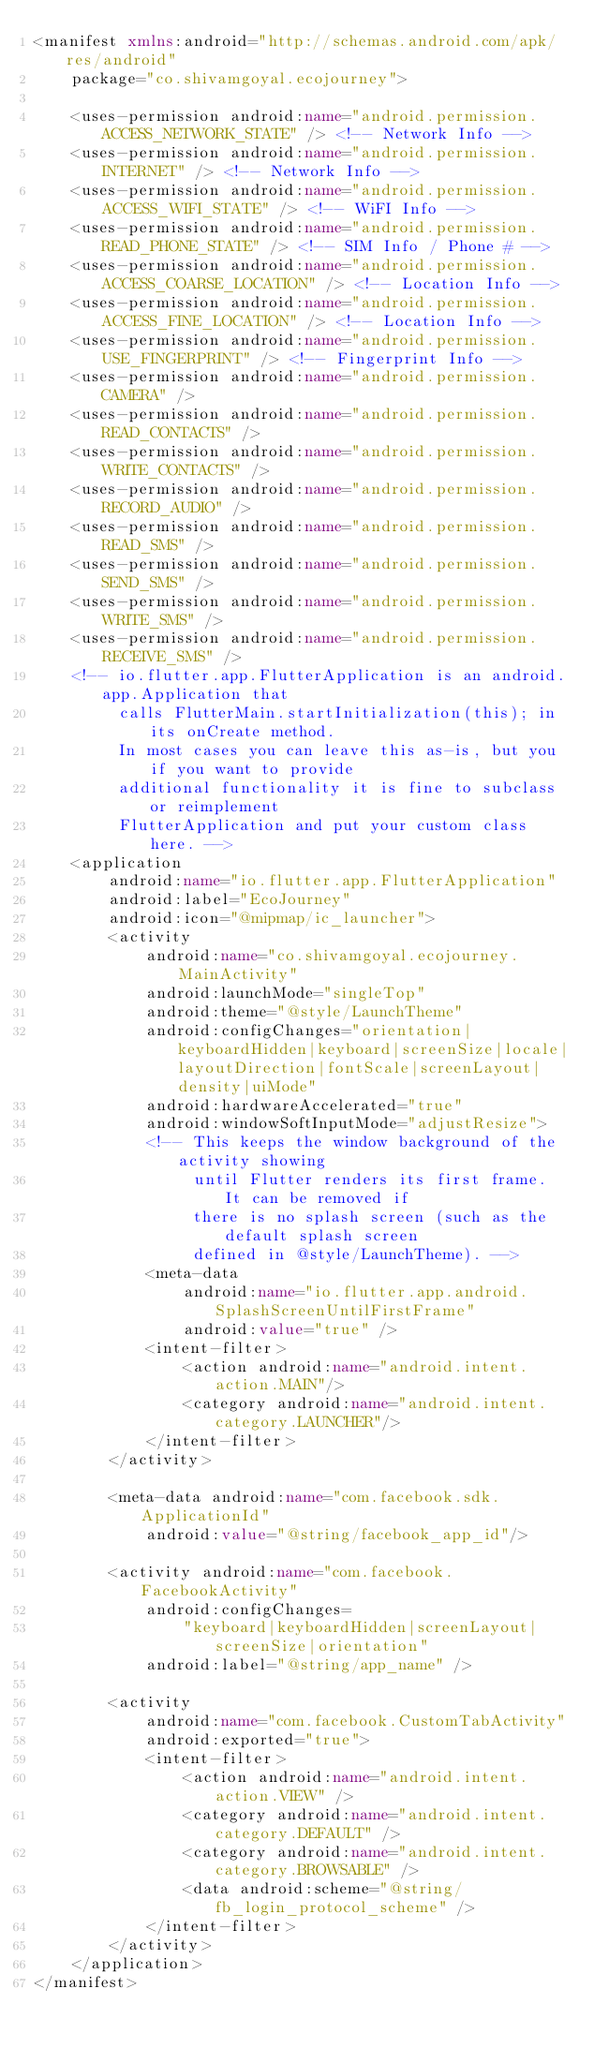Convert code to text. <code><loc_0><loc_0><loc_500><loc_500><_XML_><manifest xmlns:android="http://schemas.android.com/apk/res/android"
    package="co.shivamgoyal.ecojourney">

    <uses-permission android:name="android.permission.ACCESS_NETWORK_STATE" /> <!-- Network Info -->
    <uses-permission android:name="android.permission.INTERNET" /> <!-- Network Info -->
    <uses-permission android:name="android.permission.ACCESS_WIFI_STATE" /> <!-- WiFI Info -->
    <uses-permission android:name="android.permission.READ_PHONE_STATE" /> <!-- SIM Info / Phone # -->
    <uses-permission android:name="android.permission.ACCESS_COARSE_LOCATION" /> <!-- Location Info -->
    <uses-permission android:name="android.permission.ACCESS_FINE_LOCATION" /> <!-- Location Info -->
    <uses-permission android:name="android.permission.USE_FINGERPRINT" /> <!-- Fingerprint Info -->
    <uses-permission android:name="android.permission.CAMERA" />
    <uses-permission android:name="android.permission.READ_CONTACTS" />
    <uses-permission android:name="android.permission.WRITE_CONTACTS" />
    <uses-permission android:name="android.permission.RECORD_AUDIO" />
    <uses-permission android:name="android.permission.READ_SMS" />
    <uses-permission android:name="android.permission.SEND_SMS" />
    <uses-permission android:name="android.permission.WRITE_SMS" />
    <uses-permission android:name="android.permission.RECEIVE_SMS" />
    <!-- io.flutter.app.FlutterApplication is an android.app.Application that
         calls FlutterMain.startInitialization(this); in its onCreate method.
         In most cases you can leave this as-is, but you if you want to provide
         additional functionality it is fine to subclass or reimplement
         FlutterApplication and put your custom class here. -->
    <application
        android:name="io.flutter.app.FlutterApplication"
        android:label="EcoJourney"
        android:icon="@mipmap/ic_launcher">
        <activity
            android:name="co.shivamgoyal.ecojourney.MainActivity"
            android:launchMode="singleTop"
            android:theme="@style/LaunchTheme"
            android:configChanges="orientation|keyboardHidden|keyboard|screenSize|locale|layoutDirection|fontScale|screenLayout|density|uiMode"
            android:hardwareAccelerated="true"
            android:windowSoftInputMode="adjustResize">
            <!-- This keeps the window background of the activity showing
                 until Flutter renders its first frame. It can be removed if
                 there is no splash screen (such as the default splash screen
                 defined in @style/LaunchTheme). -->
            <meta-data
                android:name="io.flutter.app.android.SplashScreenUntilFirstFrame"
                android:value="true" />
            <intent-filter>
                <action android:name="android.intent.action.MAIN"/>
                <category android:name="android.intent.category.LAUNCHER"/>
            </intent-filter>
        </activity>

        <meta-data android:name="com.facebook.sdk.ApplicationId"
            android:value="@string/facebook_app_id"/>

        <activity android:name="com.facebook.FacebookActivity"
            android:configChanges=
                "keyboard|keyboardHidden|screenLayout|screenSize|orientation"
            android:label="@string/app_name" />

        <activity
            android:name="com.facebook.CustomTabActivity"
            android:exported="true">
            <intent-filter>
                <action android:name="android.intent.action.VIEW" />
                <category android:name="android.intent.category.DEFAULT" />
                <category android:name="android.intent.category.BROWSABLE" />
                <data android:scheme="@string/fb_login_protocol_scheme" />
            </intent-filter>
        </activity>
    </application>
</manifest>

</code> 